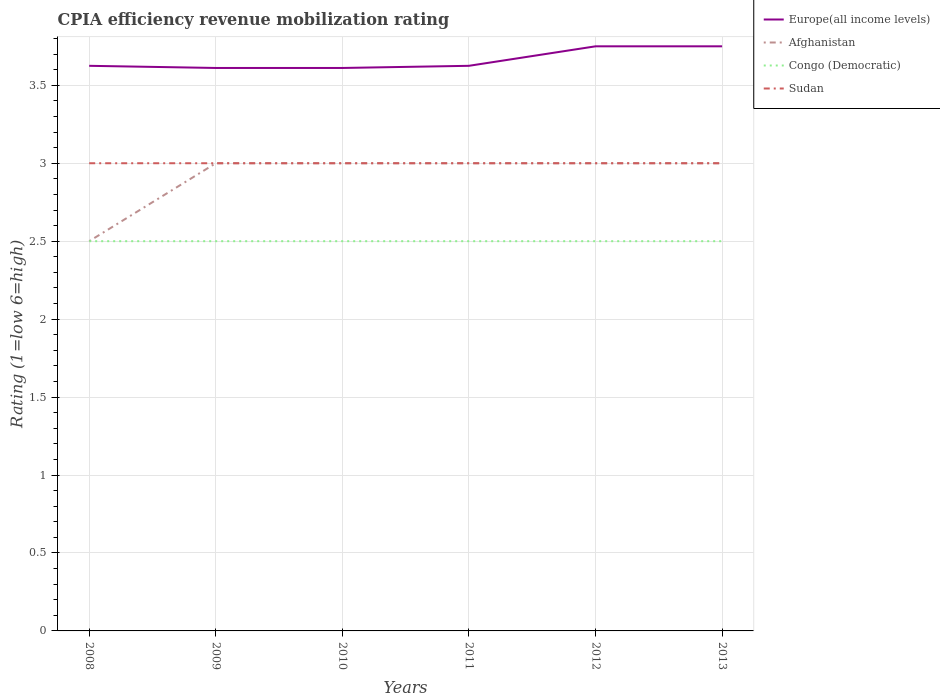How many different coloured lines are there?
Ensure brevity in your answer.  4. Does the line corresponding to Sudan intersect with the line corresponding to Congo (Democratic)?
Offer a very short reply. No. Across all years, what is the maximum CPIA rating in Congo (Democratic)?
Your response must be concise. 2.5. What is the difference between the highest and the second highest CPIA rating in Europe(all income levels)?
Offer a terse response. 0.14. What is the difference between the highest and the lowest CPIA rating in Afghanistan?
Ensure brevity in your answer.  5. Are the values on the major ticks of Y-axis written in scientific E-notation?
Provide a short and direct response. No. Does the graph contain any zero values?
Offer a very short reply. No. Does the graph contain grids?
Ensure brevity in your answer.  Yes. How many legend labels are there?
Provide a succinct answer. 4. How are the legend labels stacked?
Your answer should be very brief. Vertical. What is the title of the graph?
Keep it short and to the point. CPIA efficiency revenue mobilization rating. Does "Ghana" appear as one of the legend labels in the graph?
Provide a succinct answer. No. What is the Rating (1=low 6=high) of Europe(all income levels) in 2008?
Offer a terse response. 3.62. What is the Rating (1=low 6=high) in Congo (Democratic) in 2008?
Give a very brief answer. 2.5. What is the Rating (1=low 6=high) of Sudan in 2008?
Make the answer very short. 3. What is the Rating (1=low 6=high) in Europe(all income levels) in 2009?
Give a very brief answer. 3.61. What is the Rating (1=low 6=high) of Sudan in 2009?
Provide a short and direct response. 3. What is the Rating (1=low 6=high) in Europe(all income levels) in 2010?
Offer a very short reply. 3.61. What is the Rating (1=low 6=high) in Afghanistan in 2010?
Ensure brevity in your answer.  3. What is the Rating (1=low 6=high) in Sudan in 2010?
Offer a terse response. 3. What is the Rating (1=low 6=high) of Europe(all income levels) in 2011?
Your response must be concise. 3.62. What is the Rating (1=low 6=high) in Afghanistan in 2011?
Offer a terse response. 3. What is the Rating (1=low 6=high) in Congo (Democratic) in 2011?
Your answer should be very brief. 2.5. What is the Rating (1=low 6=high) in Europe(all income levels) in 2012?
Your response must be concise. 3.75. What is the Rating (1=low 6=high) of Afghanistan in 2012?
Offer a terse response. 3. What is the Rating (1=low 6=high) in Sudan in 2012?
Ensure brevity in your answer.  3. What is the Rating (1=low 6=high) in Europe(all income levels) in 2013?
Offer a terse response. 3.75. Across all years, what is the maximum Rating (1=low 6=high) in Europe(all income levels)?
Your response must be concise. 3.75. Across all years, what is the minimum Rating (1=low 6=high) in Europe(all income levels)?
Your answer should be compact. 3.61. Across all years, what is the minimum Rating (1=low 6=high) of Afghanistan?
Give a very brief answer. 2.5. What is the total Rating (1=low 6=high) of Europe(all income levels) in the graph?
Provide a succinct answer. 21.97. What is the total Rating (1=low 6=high) in Congo (Democratic) in the graph?
Offer a very short reply. 15. What is the total Rating (1=low 6=high) of Sudan in the graph?
Make the answer very short. 18. What is the difference between the Rating (1=low 6=high) of Europe(all income levels) in 2008 and that in 2009?
Provide a short and direct response. 0.01. What is the difference between the Rating (1=low 6=high) in Afghanistan in 2008 and that in 2009?
Make the answer very short. -0.5. What is the difference between the Rating (1=low 6=high) in Congo (Democratic) in 2008 and that in 2009?
Ensure brevity in your answer.  0. What is the difference between the Rating (1=low 6=high) of Europe(all income levels) in 2008 and that in 2010?
Make the answer very short. 0.01. What is the difference between the Rating (1=low 6=high) in Afghanistan in 2008 and that in 2010?
Give a very brief answer. -0.5. What is the difference between the Rating (1=low 6=high) in Sudan in 2008 and that in 2010?
Offer a terse response. 0. What is the difference between the Rating (1=low 6=high) of Sudan in 2008 and that in 2011?
Provide a succinct answer. 0. What is the difference between the Rating (1=low 6=high) of Europe(all income levels) in 2008 and that in 2012?
Keep it short and to the point. -0.12. What is the difference between the Rating (1=low 6=high) in Afghanistan in 2008 and that in 2012?
Your response must be concise. -0.5. What is the difference between the Rating (1=low 6=high) in Europe(all income levels) in 2008 and that in 2013?
Give a very brief answer. -0.12. What is the difference between the Rating (1=low 6=high) of Afghanistan in 2008 and that in 2013?
Your answer should be compact. -0.5. What is the difference between the Rating (1=low 6=high) in Sudan in 2008 and that in 2013?
Your answer should be very brief. 0. What is the difference between the Rating (1=low 6=high) in Afghanistan in 2009 and that in 2010?
Provide a succinct answer. 0. What is the difference between the Rating (1=low 6=high) of Sudan in 2009 and that in 2010?
Ensure brevity in your answer.  0. What is the difference between the Rating (1=low 6=high) of Europe(all income levels) in 2009 and that in 2011?
Your response must be concise. -0.01. What is the difference between the Rating (1=low 6=high) of Congo (Democratic) in 2009 and that in 2011?
Provide a succinct answer. 0. What is the difference between the Rating (1=low 6=high) in Europe(all income levels) in 2009 and that in 2012?
Keep it short and to the point. -0.14. What is the difference between the Rating (1=low 6=high) of Congo (Democratic) in 2009 and that in 2012?
Ensure brevity in your answer.  0. What is the difference between the Rating (1=low 6=high) in Sudan in 2009 and that in 2012?
Your response must be concise. 0. What is the difference between the Rating (1=low 6=high) in Europe(all income levels) in 2009 and that in 2013?
Your answer should be very brief. -0.14. What is the difference between the Rating (1=low 6=high) of Afghanistan in 2009 and that in 2013?
Provide a succinct answer. 0. What is the difference between the Rating (1=low 6=high) of Sudan in 2009 and that in 2013?
Give a very brief answer. 0. What is the difference between the Rating (1=low 6=high) of Europe(all income levels) in 2010 and that in 2011?
Your answer should be very brief. -0.01. What is the difference between the Rating (1=low 6=high) in Europe(all income levels) in 2010 and that in 2012?
Your answer should be very brief. -0.14. What is the difference between the Rating (1=low 6=high) in Congo (Democratic) in 2010 and that in 2012?
Give a very brief answer. 0. What is the difference between the Rating (1=low 6=high) of Sudan in 2010 and that in 2012?
Your answer should be compact. 0. What is the difference between the Rating (1=low 6=high) in Europe(all income levels) in 2010 and that in 2013?
Your answer should be very brief. -0.14. What is the difference between the Rating (1=low 6=high) of Congo (Democratic) in 2010 and that in 2013?
Your answer should be very brief. 0. What is the difference between the Rating (1=low 6=high) in Sudan in 2010 and that in 2013?
Provide a succinct answer. 0. What is the difference between the Rating (1=low 6=high) in Europe(all income levels) in 2011 and that in 2012?
Offer a very short reply. -0.12. What is the difference between the Rating (1=low 6=high) in Afghanistan in 2011 and that in 2012?
Keep it short and to the point. 0. What is the difference between the Rating (1=low 6=high) of Europe(all income levels) in 2011 and that in 2013?
Keep it short and to the point. -0.12. What is the difference between the Rating (1=low 6=high) of Afghanistan in 2011 and that in 2013?
Offer a terse response. 0. What is the difference between the Rating (1=low 6=high) of Sudan in 2011 and that in 2013?
Offer a very short reply. 0. What is the difference between the Rating (1=low 6=high) in Europe(all income levels) in 2012 and that in 2013?
Your answer should be very brief. 0. What is the difference between the Rating (1=low 6=high) of Congo (Democratic) in 2012 and that in 2013?
Your response must be concise. 0. What is the difference between the Rating (1=low 6=high) of Sudan in 2012 and that in 2013?
Ensure brevity in your answer.  0. What is the difference between the Rating (1=low 6=high) of Europe(all income levels) in 2008 and the Rating (1=low 6=high) of Afghanistan in 2009?
Offer a terse response. 0.62. What is the difference between the Rating (1=low 6=high) in Europe(all income levels) in 2008 and the Rating (1=low 6=high) in Congo (Democratic) in 2009?
Give a very brief answer. 1.12. What is the difference between the Rating (1=low 6=high) in Europe(all income levels) in 2008 and the Rating (1=low 6=high) in Sudan in 2009?
Offer a very short reply. 0.62. What is the difference between the Rating (1=low 6=high) in Europe(all income levels) in 2008 and the Rating (1=low 6=high) in Afghanistan in 2010?
Offer a very short reply. 0.62. What is the difference between the Rating (1=low 6=high) in Europe(all income levels) in 2008 and the Rating (1=low 6=high) in Sudan in 2010?
Keep it short and to the point. 0.62. What is the difference between the Rating (1=low 6=high) of Afghanistan in 2008 and the Rating (1=low 6=high) of Congo (Democratic) in 2010?
Your response must be concise. 0. What is the difference between the Rating (1=low 6=high) in Congo (Democratic) in 2008 and the Rating (1=low 6=high) in Sudan in 2010?
Keep it short and to the point. -0.5. What is the difference between the Rating (1=low 6=high) in Europe(all income levels) in 2008 and the Rating (1=low 6=high) in Afghanistan in 2011?
Make the answer very short. 0.62. What is the difference between the Rating (1=low 6=high) of Europe(all income levels) in 2008 and the Rating (1=low 6=high) of Sudan in 2011?
Make the answer very short. 0.62. What is the difference between the Rating (1=low 6=high) in Afghanistan in 2008 and the Rating (1=low 6=high) in Congo (Democratic) in 2011?
Offer a very short reply. 0. What is the difference between the Rating (1=low 6=high) in Europe(all income levels) in 2008 and the Rating (1=low 6=high) in Afghanistan in 2012?
Your answer should be very brief. 0.62. What is the difference between the Rating (1=low 6=high) of Europe(all income levels) in 2008 and the Rating (1=low 6=high) of Congo (Democratic) in 2012?
Make the answer very short. 1.12. What is the difference between the Rating (1=low 6=high) of Europe(all income levels) in 2008 and the Rating (1=low 6=high) of Afghanistan in 2013?
Provide a short and direct response. 0.62. What is the difference between the Rating (1=low 6=high) in Europe(all income levels) in 2008 and the Rating (1=low 6=high) in Congo (Democratic) in 2013?
Ensure brevity in your answer.  1.12. What is the difference between the Rating (1=low 6=high) in Afghanistan in 2008 and the Rating (1=low 6=high) in Sudan in 2013?
Make the answer very short. -0.5. What is the difference between the Rating (1=low 6=high) in Congo (Democratic) in 2008 and the Rating (1=low 6=high) in Sudan in 2013?
Offer a very short reply. -0.5. What is the difference between the Rating (1=low 6=high) of Europe(all income levels) in 2009 and the Rating (1=low 6=high) of Afghanistan in 2010?
Ensure brevity in your answer.  0.61. What is the difference between the Rating (1=low 6=high) of Europe(all income levels) in 2009 and the Rating (1=low 6=high) of Sudan in 2010?
Offer a very short reply. 0.61. What is the difference between the Rating (1=low 6=high) in Afghanistan in 2009 and the Rating (1=low 6=high) in Sudan in 2010?
Ensure brevity in your answer.  0. What is the difference between the Rating (1=low 6=high) of Europe(all income levels) in 2009 and the Rating (1=low 6=high) of Afghanistan in 2011?
Your response must be concise. 0.61. What is the difference between the Rating (1=low 6=high) in Europe(all income levels) in 2009 and the Rating (1=low 6=high) in Congo (Democratic) in 2011?
Provide a short and direct response. 1.11. What is the difference between the Rating (1=low 6=high) of Europe(all income levels) in 2009 and the Rating (1=low 6=high) of Sudan in 2011?
Give a very brief answer. 0.61. What is the difference between the Rating (1=low 6=high) of Europe(all income levels) in 2009 and the Rating (1=low 6=high) of Afghanistan in 2012?
Make the answer very short. 0.61. What is the difference between the Rating (1=low 6=high) of Europe(all income levels) in 2009 and the Rating (1=low 6=high) of Sudan in 2012?
Your answer should be very brief. 0.61. What is the difference between the Rating (1=low 6=high) of Afghanistan in 2009 and the Rating (1=low 6=high) of Congo (Democratic) in 2012?
Your response must be concise. 0.5. What is the difference between the Rating (1=low 6=high) in Congo (Democratic) in 2009 and the Rating (1=low 6=high) in Sudan in 2012?
Your answer should be very brief. -0.5. What is the difference between the Rating (1=low 6=high) of Europe(all income levels) in 2009 and the Rating (1=low 6=high) of Afghanistan in 2013?
Your response must be concise. 0.61. What is the difference between the Rating (1=low 6=high) in Europe(all income levels) in 2009 and the Rating (1=low 6=high) in Congo (Democratic) in 2013?
Offer a very short reply. 1.11. What is the difference between the Rating (1=low 6=high) in Europe(all income levels) in 2009 and the Rating (1=low 6=high) in Sudan in 2013?
Give a very brief answer. 0.61. What is the difference between the Rating (1=low 6=high) in Europe(all income levels) in 2010 and the Rating (1=low 6=high) in Afghanistan in 2011?
Provide a succinct answer. 0.61. What is the difference between the Rating (1=low 6=high) in Europe(all income levels) in 2010 and the Rating (1=low 6=high) in Congo (Democratic) in 2011?
Offer a terse response. 1.11. What is the difference between the Rating (1=low 6=high) in Europe(all income levels) in 2010 and the Rating (1=low 6=high) in Sudan in 2011?
Offer a terse response. 0.61. What is the difference between the Rating (1=low 6=high) in Afghanistan in 2010 and the Rating (1=low 6=high) in Sudan in 2011?
Your answer should be very brief. 0. What is the difference between the Rating (1=low 6=high) in Congo (Democratic) in 2010 and the Rating (1=low 6=high) in Sudan in 2011?
Give a very brief answer. -0.5. What is the difference between the Rating (1=low 6=high) in Europe(all income levels) in 2010 and the Rating (1=low 6=high) in Afghanistan in 2012?
Make the answer very short. 0.61. What is the difference between the Rating (1=low 6=high) in Europe(all income levels) in 2010 and the Rating (1=low 6=high) in Sudan in 2012?
Give a very brief answer. 0.61. What is the difference between the Rating (1=low 6=high) in Europe(all income levels) in 2010 and the Rating (1=low 6=high) in Afghanistan in 2013?
Ensure brevity in your answer.  0.61. What is the difference between the Rating (1=low 6=high) in Europe(all income levels) in 2010 and the Rating (1=low 6=high) in Sudan in 2013?
Provide a short and direct response. 0.61. What is the difference between the Rating (1=low 6=high) in Europe(all income levels) in 2011 and the Rating (1=low 6=high) in Afghanistan in 2012?
Provide a short and direct response. 0.62. What is the difference between the Rating (1=low 6=high) of Europe(all income levels) in 2011 and the Rating (1=low 6=high) of Sudan in 2012?
Give a very brief answer. 0.62. What is the difference between the Rating (1=low 6=high) of Afghanistan in 2011 and the Rating (1=low 6=high) of Congo (Democratic) in 2012?
Your response must be concise. 0.5. What is the difference between the Rating (1=low 6=high) in Congo (Democratic) in 2011 and the Rating (1=low 6=high) in Sudan in 2012?
Provide a succinct answer. -0.5. What is the difference between the Rating (1=low 6=high) of Europe(all income levels) in 2011 and the Rating (1=low 6=high) of Afghanistan in 2013?
Make the answer very short. 0.62. What is the difference between the Rating (1=low 6=high) of Europe(all income levels) in 2011 and the Rating (1=low 6=high) of Sudan in 2013?
Offer a terse response. 0.62. What is the difference between the Rating (1=low 6=high) of Afghanistan in 2011 and the Rating (1=low 6=high) of Congo (Democratic) in 2013?
Your answer should be compact. 0.5. What is the difference between the Rating (1=low 6=high) of Afghanistan in 2011 and the Rating (1=low 6=high) of Sudan in 2013?
Ensure brevity in your answer.  0. What is the difference between the Rating (1=low 6=high) in Congo (Democratic) in 2011 and the Rating (1=low 6=high) in Sudan in 2013?
Give a very brief answer. -0.5. What is the difference between the Rating (1=low 6=high) of Europe(all income levels) in 2012 and the Rating (1=low 6=high) of Afghanistan in 2013?
Offer a very short reply. 0.75. What is the difference between the Rating (1=low 6=high) of Afghanistan in 2012 and the Rating (1=low 6=high) of Sudan in 2013?
Your answer should be compact. 0. What is the difference between the Rating (1=low 6=high) in Congo (Democratic) in 2012 and the Rating (1=low 6=high) in Sudan in 2013?
Your response must be concise. -0.5. What is the average Rating (1=low 6=high) in Europe(all income levels) per year?
Offer a very short reply. 3.66. What is the average Rating (1=low 6=high) of Afghanistan per year?
Give a very brief answer. 2.92. What is the average Rating (1=low 6=high) in Congo (Democratic) per year?
Your answer should be compact. 2.5. In the year 2008, what is the difference between the Rating (1=low 6=high) of Europe(all income levels) and Rating (1=low 6=high) of Sudan?
Make the answer very short. 0.62. In the year 2008, what is the difference between the Rating (1=low 6=high) of Afghanistan and Rating (1=low 6=high) of Sudan?
Your answer should be very brief. -0.5. In the year 2008, what is the difference between the Rating (1=low 6=high) in Congo (Democratic) and Rating (1=low 6=high) in Sudan?
Keep it short and to the point. -0.5. In the year 2009, what is the difference between the Rating (1=low 6=high) in Europe(all income levels) and Rating (1=low 6=high) in Afghanistan?
Provide a succinct answer. 0.61. In the year 2009, what is the difference between the Rating (1=low 6=high) of Europe(all income levels) and Rating (1=low 6=high) of Sudan?
Your answer should be very brief. 0.61. In the year 2009, what is the difference between the Rating (1=low 6=high) of Afghanistan and Rating (1=low 6=high) of Sudan?
Make the answer very short. 0. In the year 2009, what is the difference between the Rating (1=low 6=high) in Congo (Democratic) and Rating (1=low 6=high) in Sudan?
Your response must be concise. -0.5. In the year 2010, what is the difference between the Rating (1=low 6=high) in Europe(all income levels) and Rating (1=low 6=high) in Afghanistan?
Your answer should be compact. 0.61. In the year 2010, what is the difference between the Rating (1=low 6=high) of Europe(all income levels) and Rating (1=low 6=high) of Sudan?
Give a very brief answer. 0.61. In the year 2010, what is the difference between the Rating (1=low 6=high) in Afghanistan and Rating (1=low 6=high) in Congo (Democratic)?
Your response must be concise. 0.5. In the year 2010, what is the difference between the Rating (1=low 6=high) in Afghanistan and Rating (1=low 6=high) in Sudan?
Offer a very short reply. 0. In the year 2011, what is the difference between the Rating (1=low 6=high) in Europe(all income levels) and Rating (1=low 6=high) in Congo (Democratic)?
Give a very brief answer. 1.12. In the year 2011, what is the difference between the Rating (1=low 6=high) in Europe(all income levels) and Rating (1=low 6=high) in Sudan?
Give a very brief answer. 0.62. In the year 2011, what is the difference between the Rating (1=low 6=high) in Congo (Democratic) and Rating (1=low 6=high) in Sudan?
Your answer should be very brief. -0.5. In the year 2012, what is the difference between the Rating (1=low 6=high) of Europe(all income levels) and Rating (1=low 6=high) of Afghanistan?
Offer a very short reply. 0.75. In the year 2012, what is the difference between the Rating (1=low 6=high) of Europe(all income levels) and Rating (1=low 6=high) of Congo (Democratic)?
Keep it short and to the point. 1.25. In the year 2012, what is the difference between the Rating (1=low 6=high) in Afghanistan and Rating (1=low 6=high) in Sudan?
Your answer should be very brief. 0. In the year 2012, what is the difference between the Rating (1=low 6=high) in Congo (Democratic) and Rating (1=low 6=high) in Sudan?
Ensure brevity in your answer.  -0.5. In the year 2013, what is the difference between the Rating (1=low 6=high) of Europe(all income levels) and Rating (1=low 6=high) of Congo (Democratic)?
Your answer should be very brief. 1.25. In the year 2013, what is the difference between the Rating (1=low 6=high) in Afghanistan and Rating (1=low 6=high) in Congo (Democratic)?
Offer a very short reply. 0.5. What is the ratio of the Rating (1=low 6=high) of Afghanistan in 2008 to that in 2009?
Ensure brevity in your answer.  0.83. What is the ratio of the Rating (1=low 6=high) of Afghanistan in 2008 to that in 2010?
Make the answer very short. 0.83. What is the ratio of the Rating (1=low 6=high) of Sudan in 2008 to that in 2010?
Offer a very short reply. 1. What is the ratio of the Rating (1=low 6=high) of Congo (Democratic) in 2008 to that in 2011?
Provide a short and direct response. 1. What is the ratio of the Rating (1=low 6=high) of Europe(all income levels) in 2008 to that in 2012?
Make the answer very short. 0.97. What is the ratio of the Rating (1=low 6=high) of Congo (Democratic) in 2008 to that in 2012?
Make the answer very short. 1. What is the ratio of the Rating (1=low 6=high) in Europe(all income levels) in 2008 to that in 2013?
Ensure brevity in your answer.  0.97. What is the ratio of the Rating (1=low 6=high) in Congo (Democratic) in 2008 to that in 2013?
Offer a very short reply. 1. What is the ratio of the Rating (1=low 6=high) of Sudan in 2008 to that in 2013?
Provide a succinct answer. 1. What is the ratio of the Rating (1=low 6=high) in Europe(all income levels) in 2009 to that in 2010?
Your answer should be compact. 1. What is the ratio of the Rating (1=low 6=high) in Afghanistan in 2009 to that in 2010?
Offer a terse response. 1. What is the ratio of the Rating (1=low 6=high) of Congo (Democratic) in 2009 to that in 2010?
Your answer should be very brief. 1. What is the ratio of the Rating (1=low 6=high) in Sudan in 2009 to that in 2010?
Offer a very short reply. 1. What is the ratio of the Rating (1=low 6=high) in Afghanistan in 2009 to that in 2011?
Your response must be concise. 1. What is the ratio of the Rating (1=low 6=high) in Congo (Democratic) in 2009 to that in 2011?
Your response must be concise. 1. What is the ratio of the Rating (1=low 6=high) of Europe(all income levels) in 2009 to that in 2012?
Offer a terse response. 0.96. What is the ratio of the Rating (1=low 6=high) in Afghanistan in 2009 to that in 2012?
Ensure brevity in your answer.  1. What is the ratio of the Rating (1=low 6=high) in Europe(all income levels) in 2009 to that in 2013?
Keep it short and to the point. 0.96. What is the ratio of the Rating (1=low 6=high) in Afghanistan in 2009 to that in 2013?
Ensure brevity in your answer.  1. What is the ratio of the Rating (1=low 6=high) of Congo (Democratic) in 2009 to that in 2013?
Provide a short and direct response. 1. What is the ratio of the Rating (1=low 6=high) in Europe(all income levels) in 2010 to that in 2011?
Offer a very short reply. 1. What is the ratio of the Rating (1=low 6=high) in Afghanistan in 2010 to that in 2011?
Provide a succinct answer. 1. What is the ratio of the Rating (1=low 6=high) of Congo (Democratic) in 2010 to that in 2011?
Your answer should be compact. 1. What is the ratio of the Rating (1=low 6=high) in Europe(all income levels) in 2010 to that in 2012?
Your answer should be very brief. 0.96. What is the ratio of the Rating (1=low 6=high) of Congo (Democratic) in 2010 to that in 2012?
Offer a very short reply. 1. What is the ratio of the Rating (1=low 6=high) of Sudan in 2010 to that in 2012?
Make the answer very short. 1. What is the ratio of the Rating (1=low 6=high) of Europe(all income levels) in 2010 to that in 2013?
Provide a short and direct response. 0.96. What is the ratio of the Rating (1=low 6=high) in Sudan in 2010 to that in 2013?
Keep it short and to the point. 1. What is the ratio of the Rating (1=low 6=high) of Europe(all income levels) in 2011 to that in 2012?
Provide a short and direct response. 0.97. What is the ratio of the Rating (1=low 6=high) in Afghanistan in 2011 to that in 2012?
Your answer should be very brief. 1. What is the ratio of the Rating (1=low 6=high) of Congo (Democratic) in 2011 to that in 2012?
Ensure brevity in your answer.  1. What is the ratio of the Rating (1=low 6=high) in Europe(all income levels) in 2011 to that in 2013?
Your answer should be very brief. 0.97. What is the ratio of the Rating (1=low 6=high) of Congo (Democratic) in 2011 to that in 2013?
Provide a succinct answer. 1. What is the ratio of the Rating (1=low 6=high) of Sudan in 2011 to that in 2013?
Provide a succinct answer. 1. What is the ratio of the Rating (1=low 6=high) in Afghanistan in 2012 to that in 2013?
Offer a terse response. 1. What is the ratio of the Rating (1=low 6=high) in Sudan in 2012 to that in 2013?
Your response must be concise. 1. What is the difference between the highest and the second highest Rating (1=low 6=high) in Afghanistan?
Make the answer very short. 0. What is the difference between the highest and the second highest Rating (1=low 6=high) in Congo (Democratic)?
Ensure brevity in your answer.  0. What is the difference between the highest and the second highest Rating (1=low 6=high) in Sudan?
Ensure brevity in your answer.  0. What is the difference between the highest and the lowest Rating (1=low 6=high) of Europe(all income levels)?
Offer a very short reply. 0.14. What is the difference between the highest and the lowest Rating (1=low 6=high) in Congo (Democratic)?
Make the answer very short. 0. 